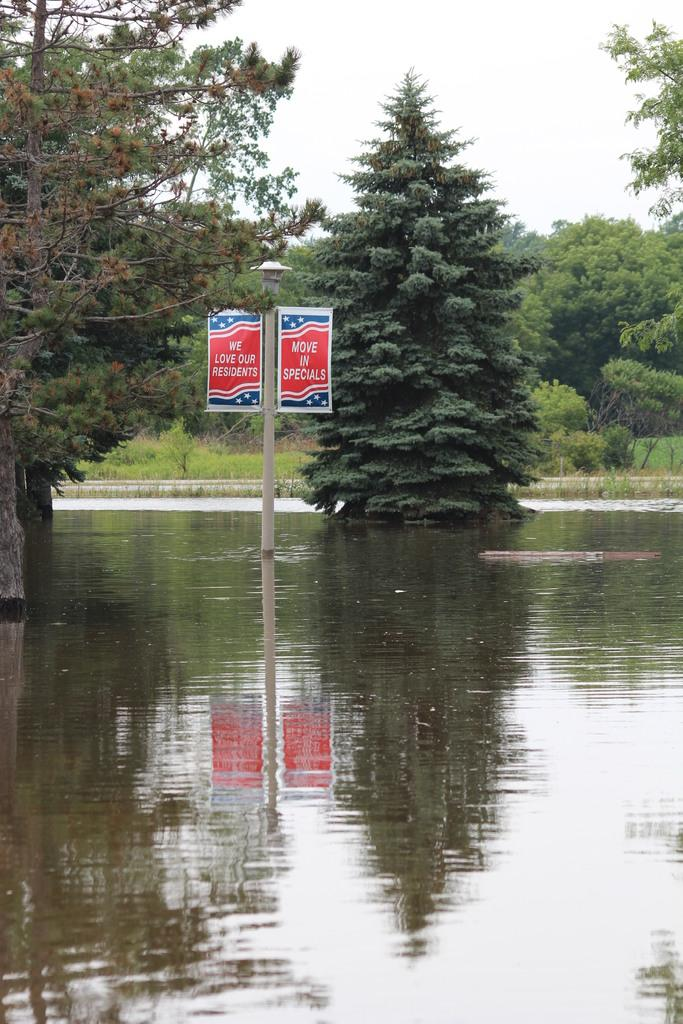What type of vegetation can be seen in the image? There are trees and grass in the image. What else is present in the image besides vegetation? There is a poster and water visible in the image. What is visible at the top of the image? The sky is visible at the top of the image. Can you tell me how many pears are being used to express hate in the image? There are no pears present in the image, and the concept of expressing hate is not mentioned or depicted. 